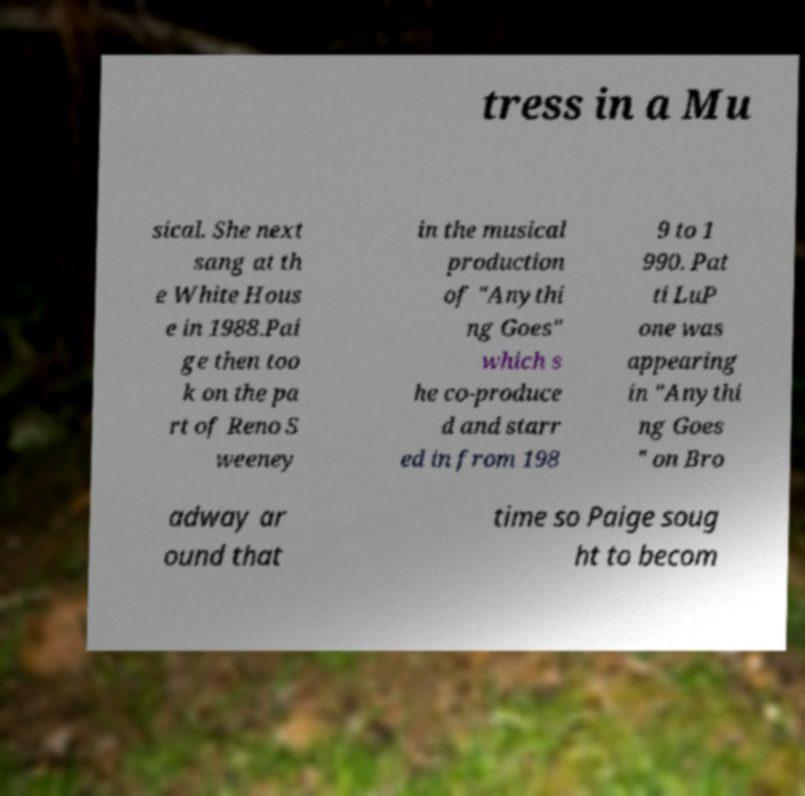Please read and relay the text visible in this image. What does it say? tress in a Mu sical. She next sang at th e White Hous e in 1988.Pai ge then too k on the pa rt of Reno S weeney in the musical production of "Anythi ng Goes" which s he co-produce d and starr ed in from 198 9 to 1 990. Pat ti LuP one was appearing in "Anythi ng Goes " on Bro adway ar ound that time so Paige soug ht to becom 